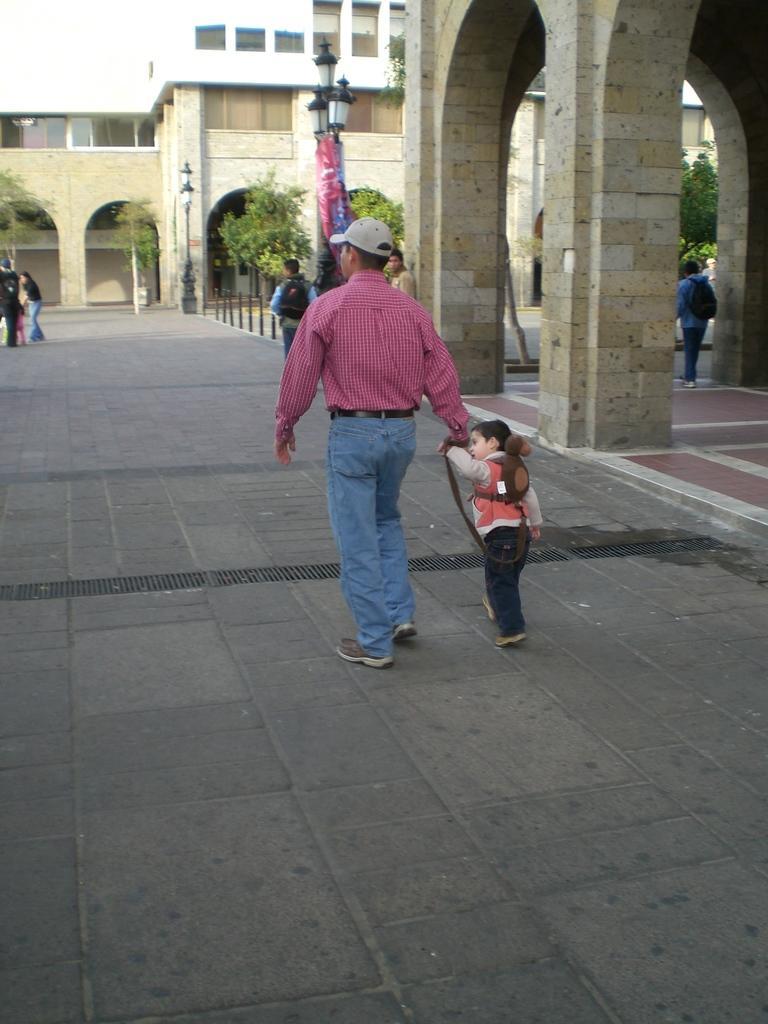Describe this image in one or two sentences. In this picture I can see few people standing and couple of them walking and I can see buildings and few pole lights and I can see trees and a cloudy sky. 